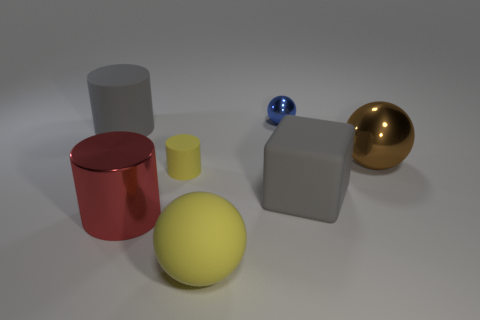Subtract all metal cylinders. How many cylinders are left? 2 Subtract all red cylinders. How many cylinders are left? 2 Add 2 yellow matte balls. How many objects exist? 9 Subtract all red blocks. Subtract all gray balls. How many blocks are left? 1 Subtract all tiny matte cylinders. Subtract all big brown shiny objects. How many objects are left? 5 Add 7 small yellow matte cylinders. How many small yellow matte cylinders are left? 8 Add 5 tiny red shiny cylinders. How many tiny red shiny cylinders exist? 5 Subtract 0 green balls. How many objects are left? 7 Subtract all balls. How many objects are left? 4 